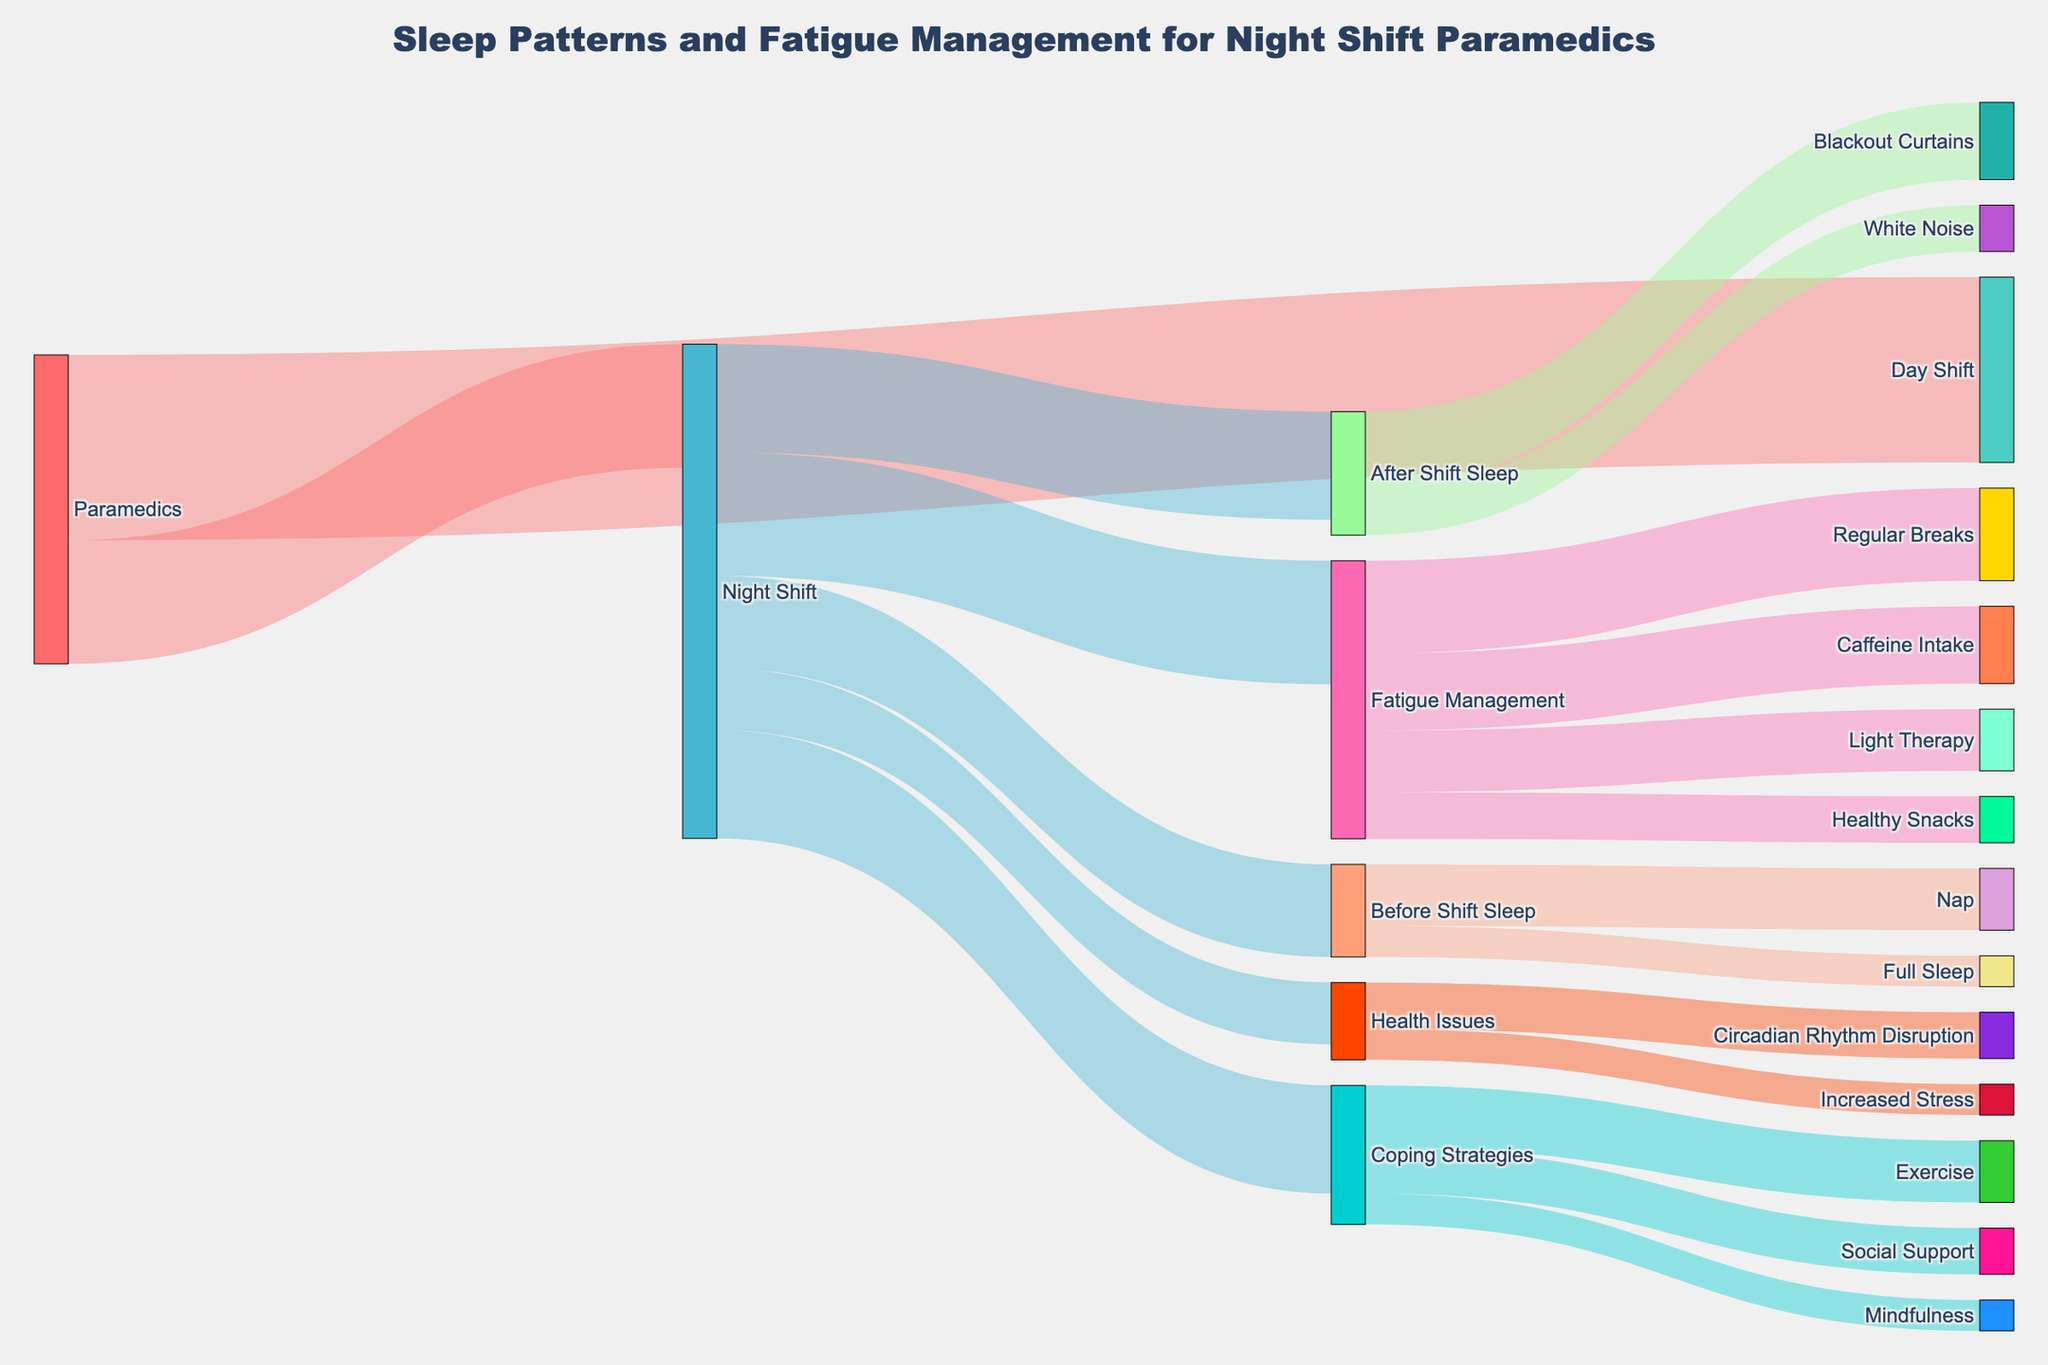What is the title of the Sankey Diagram? The title is located at the top of the diagram and provides a summary of its content.
Answer: Sleep Patterns and Fatigue Management for Night Shift Paramedics How many paramedics work the night shift? The diagram shows the split of paramedics into day and night shifts. The connection from 'Paramedics' to 'Night Shift' indicates the number.
Answer: 40 What fatigue management strategy has the highest number of paramedics? Examine the connections stemming from 'Fatigue Management' and compare the 'values' displayed alongside each strategy.
Answer: Regular Breaks How many paramedics utilize 'Blackout Curtains'? The diagram indicates paths between 'After Shift Sleep' and 'Blackout Curtains', displaying the number of paramedics.
Answer: 25 What are the categories listed under 'Health Issues'? The 'Health Issues' node connects to different categories. By following these links, one can identify each sub-category.
Answer: Circadian Rhythm Disruption, Increased Stress How many paramedics take naps before their night shifts? Look for the node labeled 'Before Shift Sleep' and follow its connections to 'Nap', noting the number next to the link.
Answer: 20 Compare the number of paramedics using 'Exercise' as a coping strategy to those experiencing 'Circadian Rhythm Disruption'. Trace the paths from 'Coping Strategies' to 'Exercise' and from 'Health Issues' to 'Circadian Rhythm Disruption' and compare the numbers.
Answer: Exercise (20) is greater than Circadian Rhythm Disruption (15) What is the combined total of paramedics benefiting from either 'Blackout Curtains' or 'White Noise' after their shift? Sum the values next to 'Blackout Curtains' (25) and 'White Noise' (15) which stem from the 'After Shift Sleep' node.
Answer: 40 Which category, 'Coping Strategies' or 'Health Issues', has more total connections? Count the number of outgoing links for both 'Coping Strategies' and 'Health Issues', respectively.
Answer: Coping Strategies What is the difference in the number of paramedics using 'Caffeine Intake' versus 'Healthy Snacks' for fatigue management? Identify values next to 'Caffeine Intake' (25) and 'Healthy Snacks' (15) from the 'Fatigue Management' node, and calculate the difference.
Answer: 10 